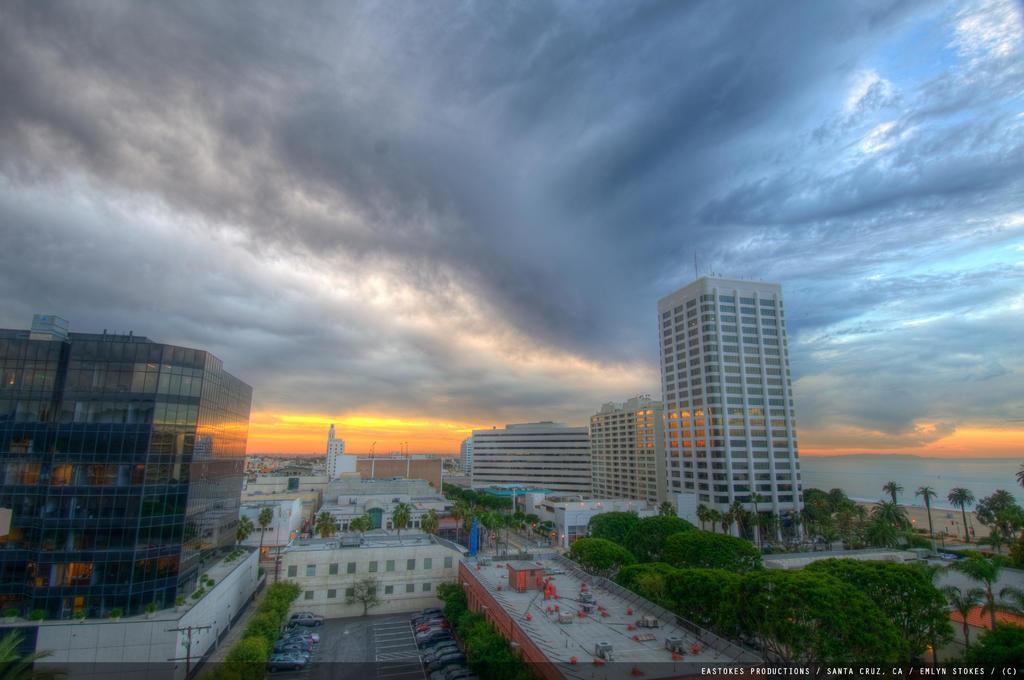How would you summarize this image in a sentence or two? In this image there are vehicles parked on the path , there are buildings, trees, water, and in the background there is sky and a watermark on the image. 